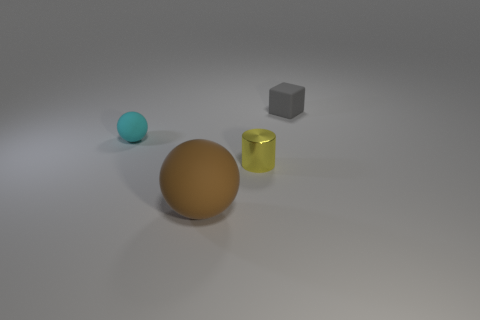What is the tiny thing that is behind the tiny thing on the left side of the tiny yellow thing made of?
Provide a succinct answer. Rubber. What shape is the small object that is both in front of the block and behind the metal cylinder?
Offer a terse response. Sphere. How many objects are small objects on the left side of the cube or gray matte blocks?
Make the answer very short. 3. Is the color of the small cube the same as the tiny thing on the left side of the large brown matte sphere?
Your answer should be very brief. No. Are there any other things that are the same size as the cyan thing?
Keep it short and to the point. Yes. There is a matte object that is in front of the tiny matte thing to the left of the tiny cube; how big is it?
Keep it short and to the point. Large. What number of objects are cyan objects or small cubes that are behind the big ball?
Offer a terse response. 2. There is a small rubber thing on the left side of the small gray rubber block; is its shape the same as the tiny yellow metallic object?
Ensure brevity in your answer.  No. How many shiny things are on the right side of the small metallic thing in front of the ball that is behind the cylinder?
Provide a short and direct response. 0. Is there any other thing that has the same shape as the gray matte object?
Ensure brevity in your answer.  No. 